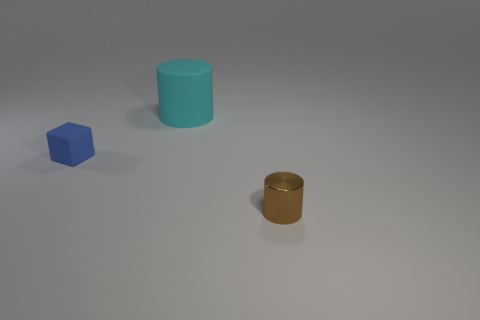Add 1 tiny red shiny spheres. How many objects exist? 4 Subtract all brown cylinders. How many cylinders are left? 1 Subtract 1 cylinders. How many cylinders are left? 1 Subtract all large cyan things. Subtract all small gray metal cylinders. How many objects are left? 2 Add 1 matte cylinders. How many matte cylinders are left? 2 Add 2 cyan things. How many cyan things exist? 3 Subtract 0 green cylinders. How many objects are left? 3 Subtract all cylinders. How many objects are left? 1 Subtract all blue cylinders. Subtract all red blocks. How many cylinders are left? 2 